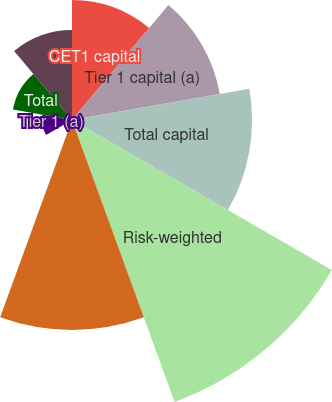Convert chart to OTSL. <chart><loc_0><loc_0><loc_500><loc_500><pie_chart><fcel>CET1 capital<fcel>Tier 1 capital (a)<fcel>Total capital<fcel>Risk-weighted<fcel>Adjusted average (b)<fcel>CET1<fcel>Tier 1 (a)<fcel>Total<fcel>Tier 1 leverage (d)<nl><fcel>10.53%<fcel>13.16%<fcel>15.79%<fcel>26.31%<fcel>18.42%<fcel>0.0%<fcel>2.63%<fcel>5.26%<fcel>7.9%<nl></chart> 